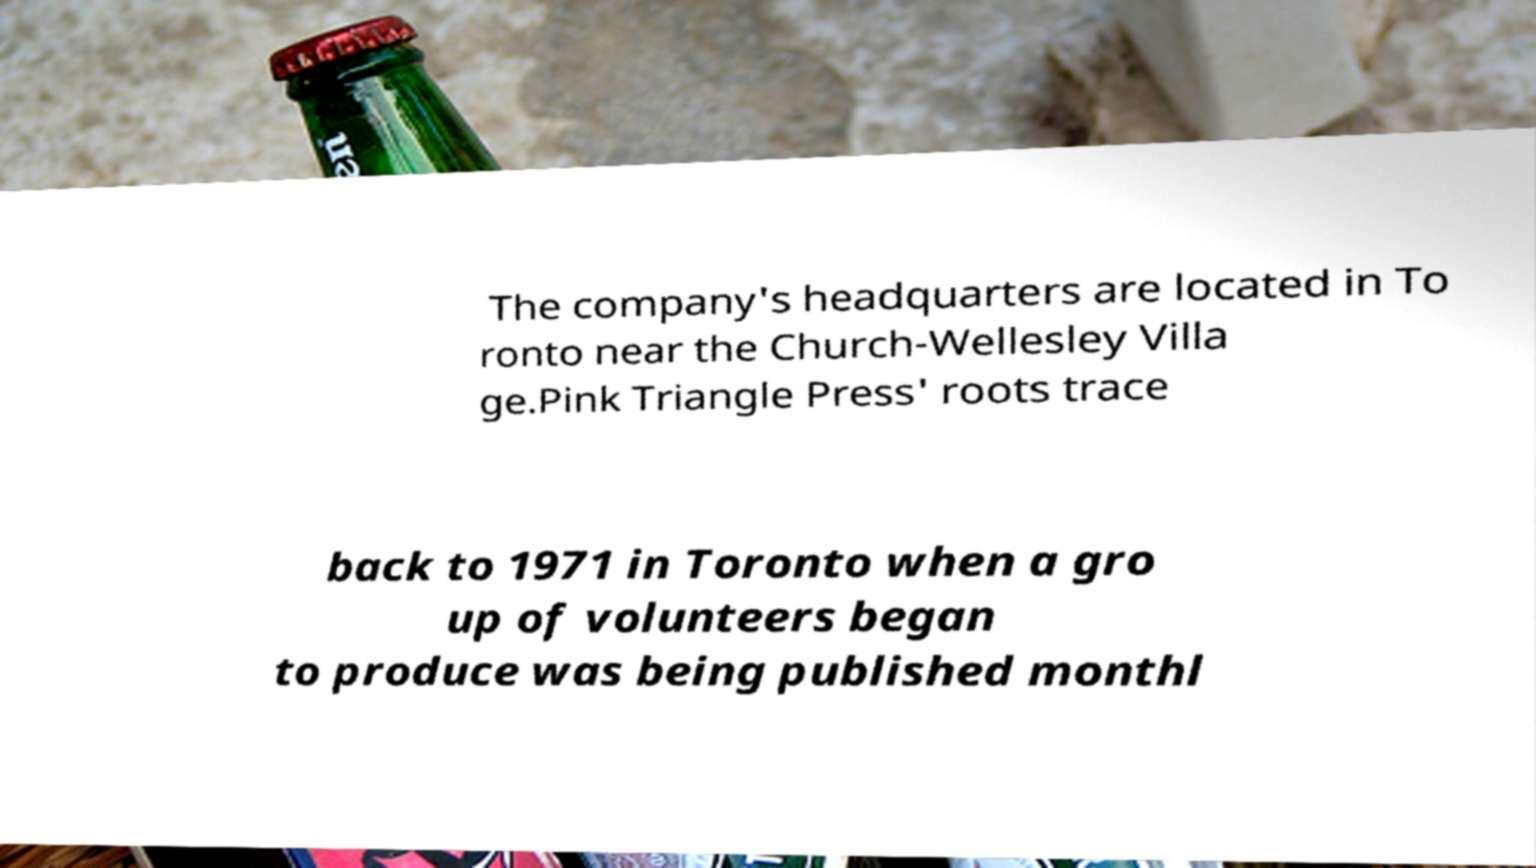Can you read and provide the text displayed in the image?This photo seems to have some interesting text. Can you extract and type it out for me? The company's headquarters are located in To ronto near the Church-Wellesley Villa ge.Pink Triangle Press' roots trace back to 1971 in Toronto when a gro up of volunteers began to produce was being published monthl 